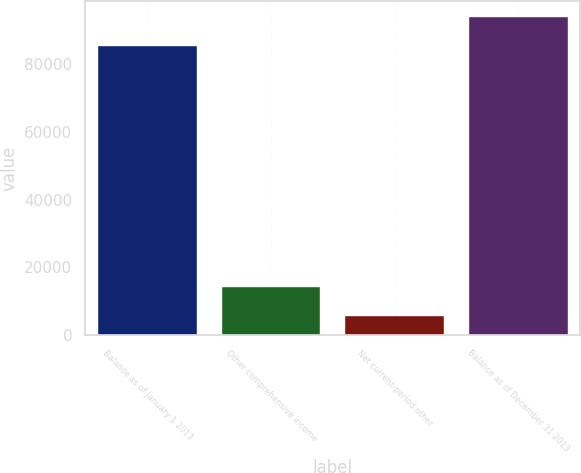Convert chart to OTSL. <chart><loc_0><loc_0><loc_500><loc_500><bar_chart><fcel>Balance as of January 1 2013<fcel>Other comprehensive income<fcel>Net current-period other<fcel>Balance as of December 31 2013<nl><fcel>85404<fcel>14113.4<fcel>5573<fcel>93944.4<nl></chart> 